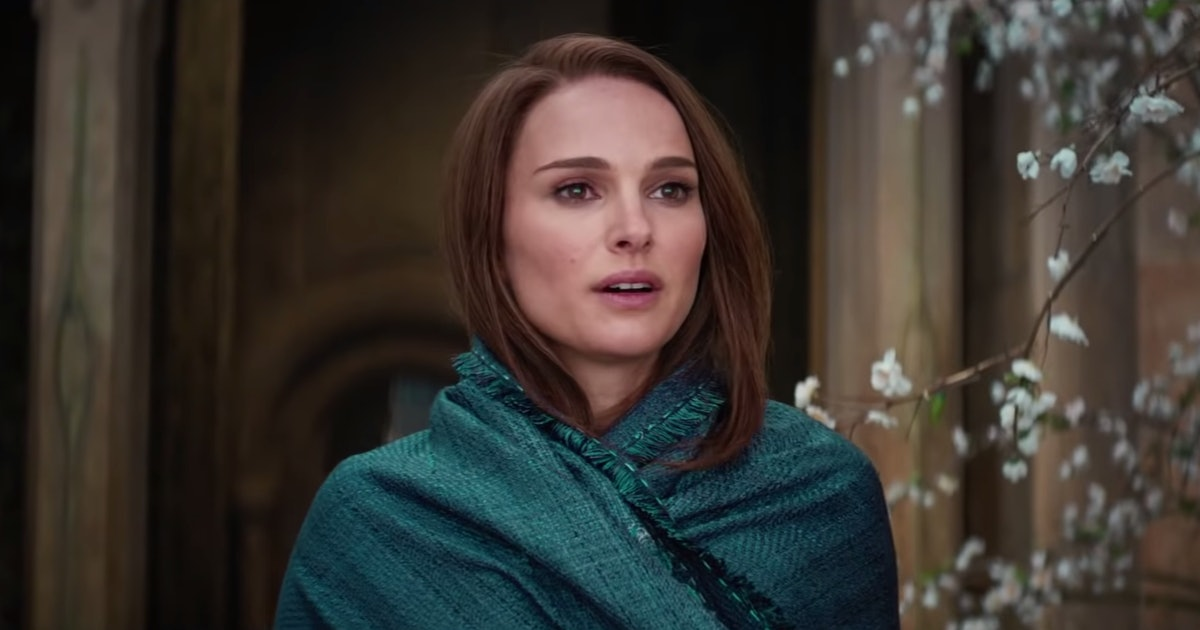How does the color of her shawl contribute to the overall mood of this scene? The blue-green shawl adds a touch of calmness and tranquility to the scene. Its rich, deep color contrasts with the softer, more neutral background, drawing attention to the figure and emphasizing her reflective mood. This choice of color not only highlights her as the focal point but also enhances the peaceful, almost contemplative quality of the setting. 